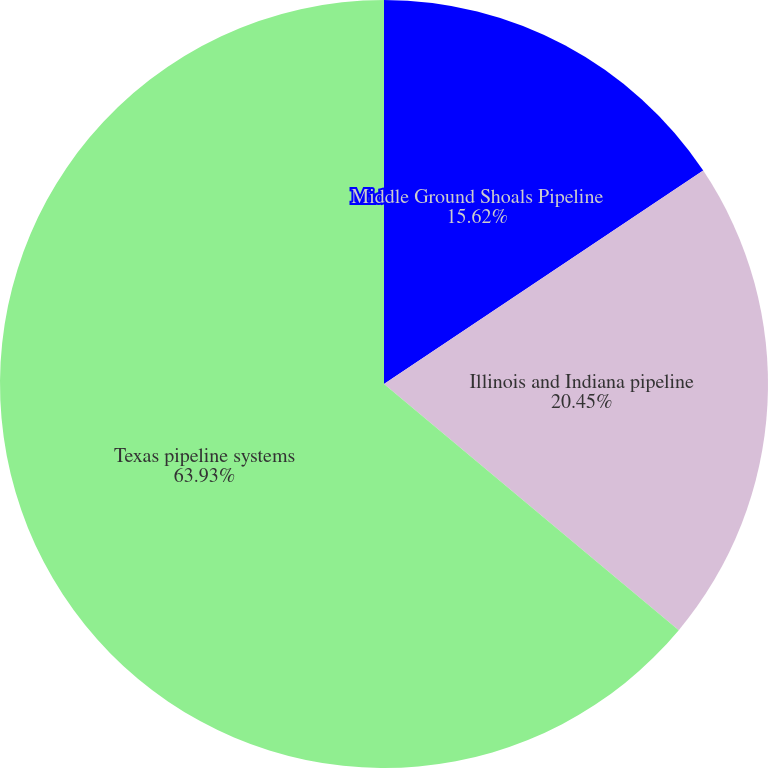<chart> <loc_0><loc_0><loc_500><loc_500><pie_chart><fcel>Middle Ground Shoals Pipeline<fcel>Illinois and Indiana pipeline<fcel>Texas pipeline systems<nl><fcel>15.62%<fcel>20.45%<fcel>63.92%<nl></chart> 